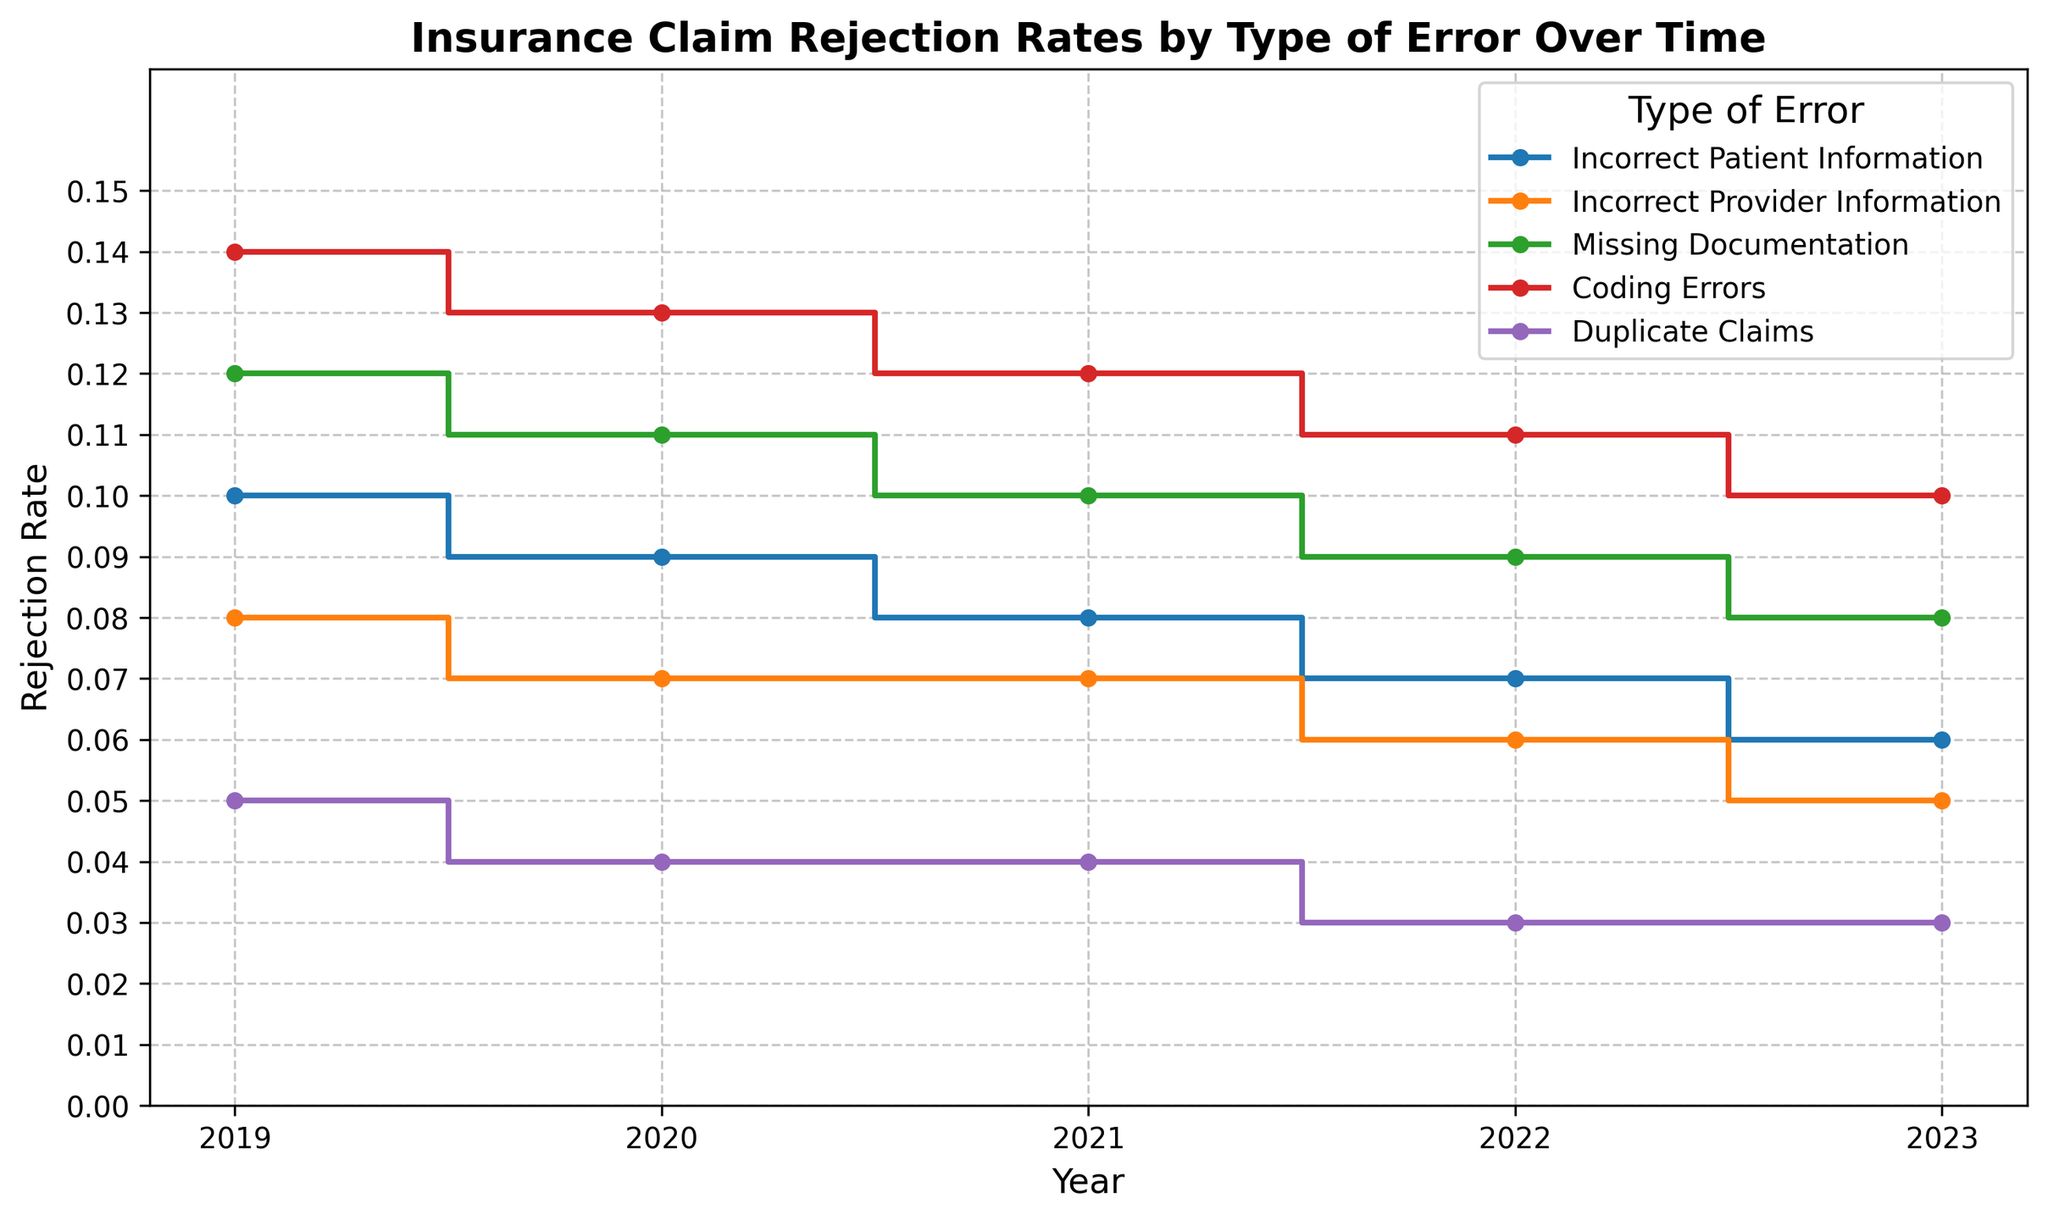Which type of error had the highest rejection rate in 2019? From the plot, look at the year 2019 and find the highest step. The tallest step represents "Coding Errors" at 0.14.
Answer: Coding Errors Which error type showed the most consistent decrease in rejection rates from 2019 to 2023? Trace each error type's step from 2019 to 2023 and observe the trend. "Incorrect Patient Information" shows a consistent decline from 0.10 to 0.06.
Answer: Incorrect Patient Information Between which two consecutive years did "Missing Documentation" see the largest drop in rejection rate? Find the step representing "Missing Documentation" and note the heights at each year. The drop from 0.10 in 2021 to 0.09 in 2022 is the largest decrease.
Answer: Between 2021 and 2022 What's the average rejection rate of Duplicate Claims over the given period? Sum the rejection rates for Duplicate Claims (0.05 + 0.04 + 0.04 + 0.03 + 0.03 = 0.19) and divide by the number of years (5). The average is 0.19/5.
Answer: 0.038 Which type of error had the smallest absolute change in rejection rate from 2019 to 2023? Calculate the absolute changes for each error type: Incorrect Patient Information (0.10 - 0.06 = 0.04), Incorrect Provider Information (0.08 - 0.05 = 0.03), Missing Documentation (0.12 - 0.08 = 0.04), Coding Errors (0.14 - 0.10 = 0.04), and Duplicate Claims (0.05 - 0.03 = 0.02).
Answer: Duplicate Claims For which year did "Coding Errors" peak in rejection rate? Look at the step heights for "Coding Errors" across all years. The highest rate is in 2019 at 0.14.
Answer: 2019 